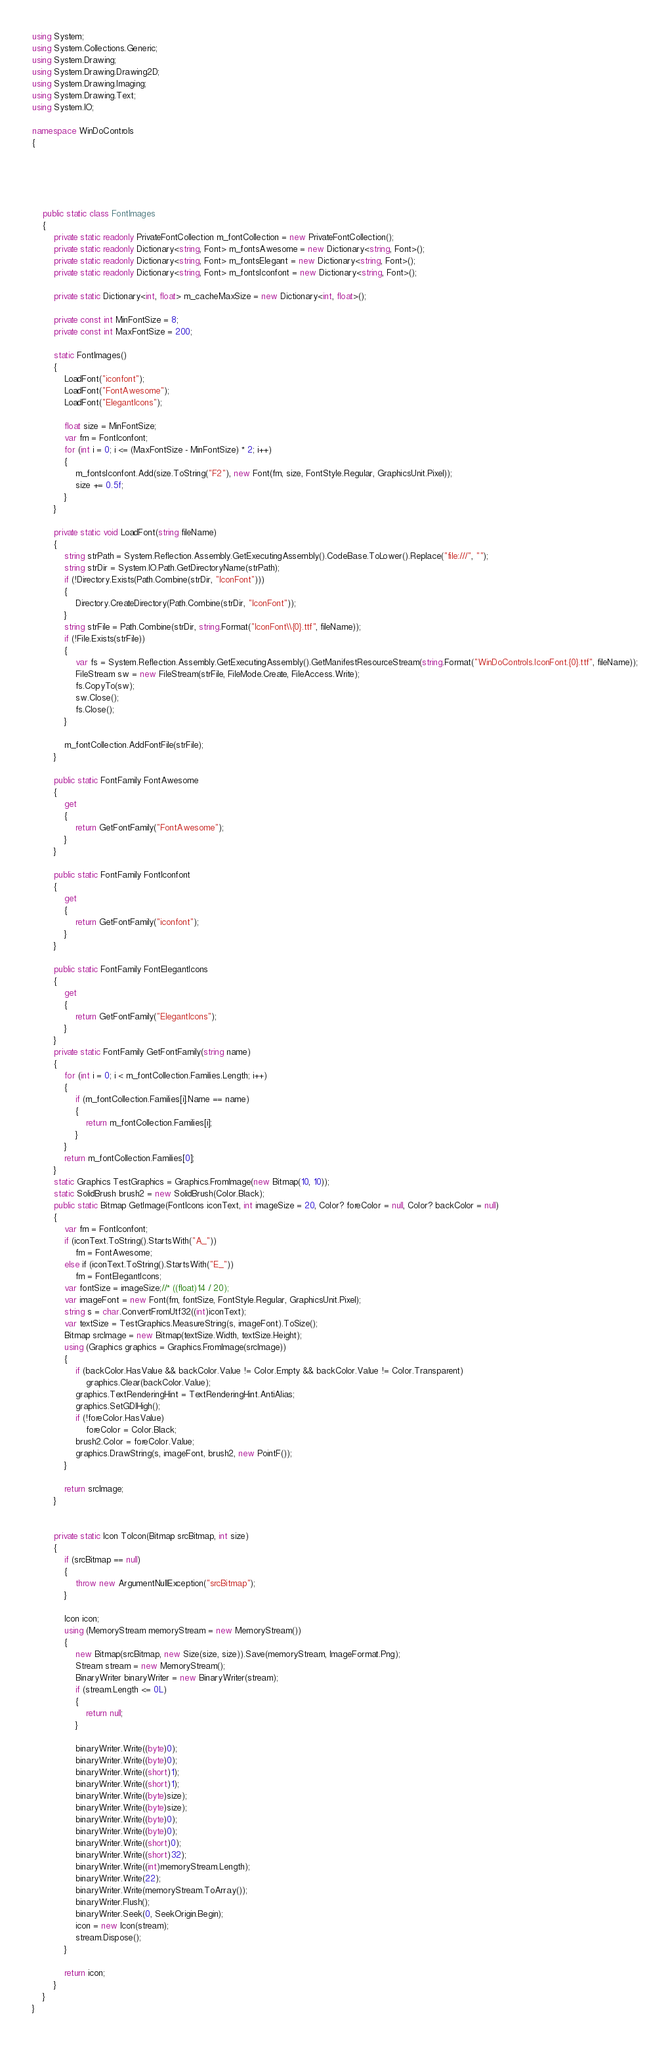<code> <loc_0><loc_0><loc_500><loc_500><_C#_>














using System;
using System.Collections.Generic;
using System.Drawing;
using System.Drawing.Drawing2D;
using System.Drawing.Imaging;
using System.Drawing.Text;
using System.IO;

namespace WinDoControls
{





    public static class FontImages
    {
        private static readonly PrivateFontCollection m_fontCollection = new PrivateFontCollection();
        private static readonly Dictionary<string, Font> m_fontsAwesome = new Dictionary<string, Font>();
        private static readonly Dictionary<string, Font> m_fontsElegant = new Dictionary<string, Font>();
        private static readonly Dictionary<string, Font> m_fontsIconfont = new Dictionary<string, Font>();

        private static Dictionary<int, float> m_cacheMaxSize = new Dictionary<int, float>();

        private const int MinFontSize = 8;
        private const int MaxFontSize = 200;

        static FontImages()
        {
            LoadFont("iconfont");
            LoadFont("FontAwesome");
            LoadFont("ElegantIcons");

            float size = MinFontSize;
            var fm = FontIconfont;
            for (int i = 0; i <= (MaxFontSize - MinFontSize) * 2; i++)
            {
                m_fontsIconfont.Add(size.ToString("F2"), new Font(fm, size, FontStyle.Regular, GraphicsUnit.Pixel));
                size += 0.5f;
            }
        }

        private static void LoadFont(string fileName)
        {
            string strPath = System.Reflection.Assembly.GetExecutingAssembly().CodeBase.ToLower().Replace("file:///", "");
            string strDir = System.IO.Path.GetDirectoryName(strPath);
            if (!Directory.Exists(Path.Combine(strDir, "IconFont")))
            {
                Directory.CreateDirectory(Path.Combine(strDir, "IconFont"));
            }
            string strFile = Path.Combine(strDir, string.Format("IconFont\\{0}.ttf", fileName));
            if (!File.Exists(strFile))
            {
                var fs = System.Reflection.Assembly.GetExecutingAssembly().GetManifestResourceStream(string.Format("WinDoControls.IconFont.{0}.ttf", fileName));
                FileStream sw = new FileStream(strFile, FileMode.Create, FileAccess.Write);
                fs.CopyTo(sw);
                sw.Close();
                fs.Close();
            }

            m_fontCollection.AddFontFile(strFile);
        }

        public static FontFamily FontAwesome
        {
            get
            {
                return GetFontFamily("FontAwesome");
            }
        }

        public static FontFamily FontIconfont
        {
            get
            {
                return GetFontFamily("iconfont");
            }
        }

        public static FontFamily FontElegantIcons
        {
            get
            {
                return GetFontFamily("ElegantIcons");
            }
        }
        private static FontFamily GetFontFamily(string name)
        {
            for (int i = 0; i < m_fontCollection.Families.Length; i++)
            {
                if (m_fontCollection.Families[i].Name == name)
                {
                    return m_fontCollection.Families[i];
                }
            }
            return m_fontCollection.Families[0];
        }
        static Graphics TestGraphics = Graphics.FromImage(new Bitmap(10, 10));
        static SolidBrush brush2 = new SolidBrush(Color.Black);
        public static Bitmap GetImage(FontIcons iconText, int imageSize = 20, Color? foreColor = null, Color? backColor = null)
        {
            var fm = FontIconfont;
            if (iconText.ToString().StartsWith("A_"))
                fm = FontAwesome;
            else if (iconText.ToString().StartsWith("E_"))
                fm = FontElegantIcons;
            var fontSize = imageSize;//* ((float)14 / 20);
            var imageFont = new Font(fm, fontSize, FontStyle.Regular, GraphicsUnit.Pixel);
            string s = char.ConvertFromUtf32((int)iconText);
            var textSize = TestGraphics.MeasureString(s, imageFont).ToSize();
            Bitmap srcImage = new Bitmap(textSize.Width, textSize.Height);
            using (Graphics graphics = Graphics.FromImage(srcImage))
            {
                if (backColor.HasValue && backColor.Value != Color.Empty && backColor.Value != Color.Transparent)
                    graphics.Clear(backColor.Value);
                graphics.TextRenderingHint = TextRenderingHint.AntiAlias;
                graphics.SetGDIHigh();
                if (!foreColor.HasValue)
                    foreColor = Color.Black;
                brush2.Color = foreColor.Value;
                graphics.DrawString(s, imageFont, brush2, new PointF());
            }

            return srcImage;
        }


        private static Icon ToIcon(Bitmap srcBitmap, int size)
        {
            if (srcBitmap == null)
            {
                throw new ArgumentNullException("srcBitmap");
            }

            Icon icon;
            using (MemoryStream memoryStream = new MemoryStream())
            {
                new Bitmap(srcBitmap, new Size(size, size)).Save(memoryStream, ImageFormat.Png);
                Stream stream = new MemoryStream();
                BinaryWriter binaryWriter = new BinaryWriter(stream);
                if (stream.Length <= 0L)
                {
                    return null;
                }

                binaryWriter.Write((byte)0);
                binaryWriter.Write((byte)0);
                binaryWriter.Write((short)1);
                binaryWriter.Write((short)1);
                binaryWriter.Write((byte)size);
                binaryWriter.Write((byte)size);
                binaryWriter.Write((byte)0);
                binaryWriter.Write((byte)0);
                binaryWriter.Write((short)0);
                binaryWriter.Write((short)32);
                binaryWriter.Write((int)memoryStream.Length);
                binaryWriter.Write(22);
                binaryWriter.Write(memoryStream.ToArray());
                binaryWriter.Flush();
                binaryWriter.Seek(0, SeekOrigin.Begin);
                icon = new Icon(stream);
                stream.Dispose();
            }

            return icon;
        }
    }
}</code> 